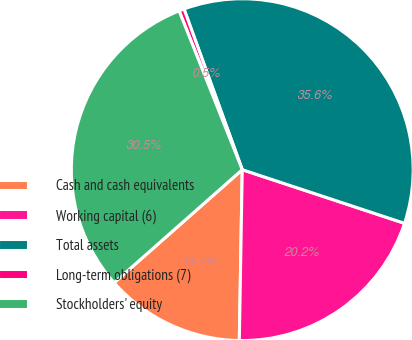<chart> <loc_0><loc_0><loc_500><loc_500><pie_chart><fcel>Cash and cash equivalents<fcel>Working capital (6)<fcel>Total assets<fcel>Long-term obligations (7)<fcel>Stockholders' equity<nl><fcel>13.22%<fcel>20.19%<fcel>35.61%<fcel>0.49%<fcel>30.48%<nl></chart> 